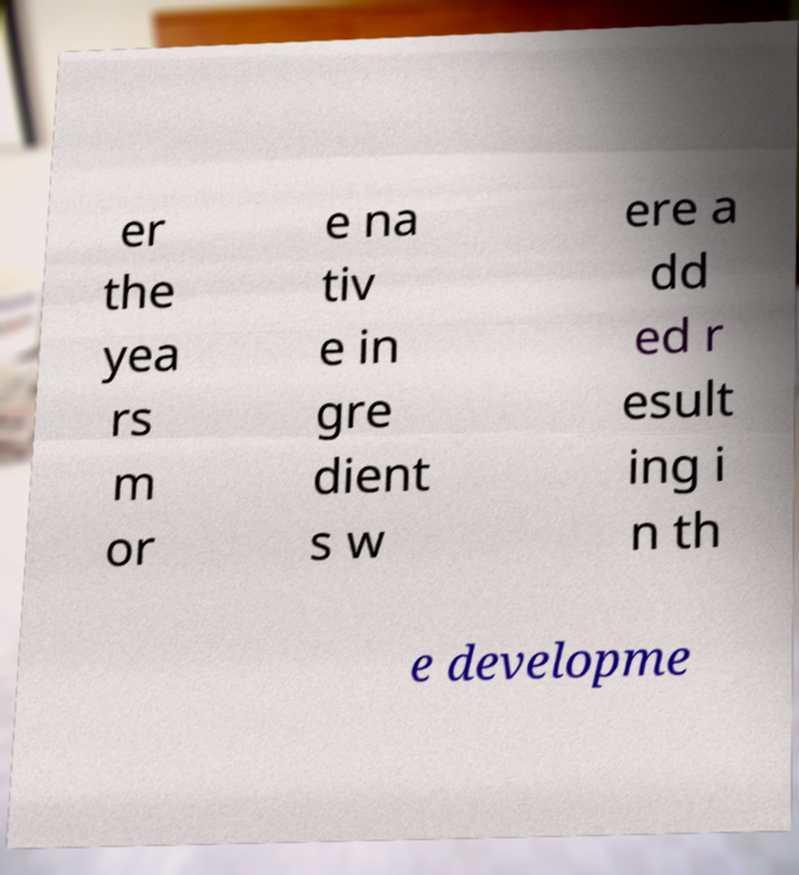Could you extract and type out the text from this image? er the yea rs m or e na tiv e in gre dient s w ere a dd ed r esult ing i n th e developme 